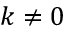Convert formula to latex. <formula><loc_0><loc_0><loc_500><loc_500>k \neq 0</formula> 